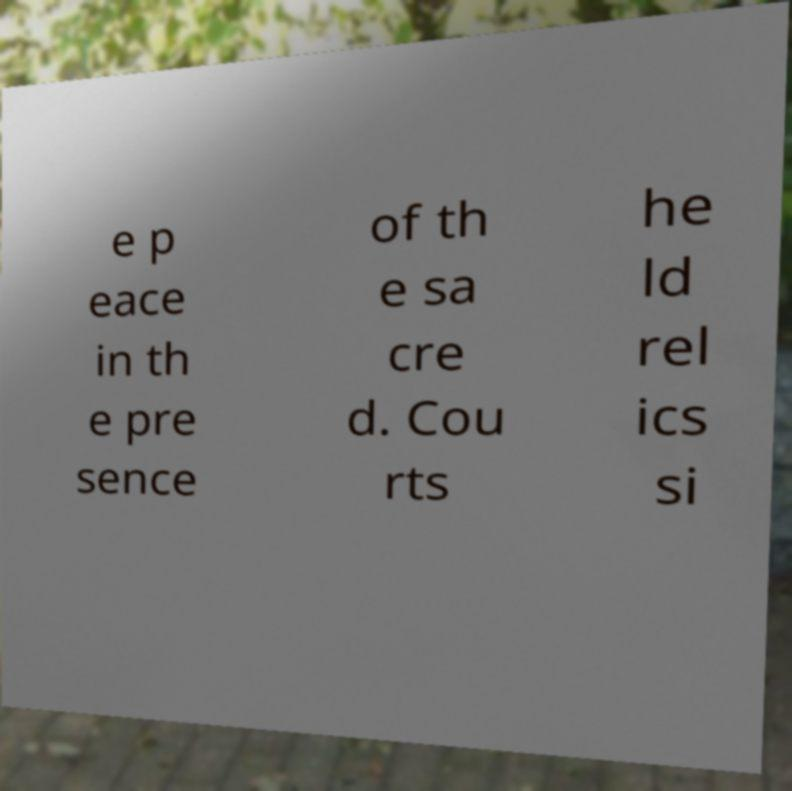I need the written content from this picture converted into text. Can you do that? e p eace in th e pre sence of th e sa cre d. Cou rts he ld rel ics si 